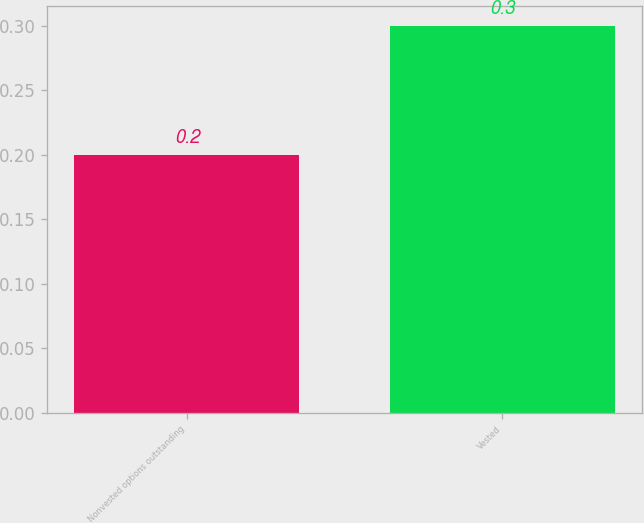<chart> <loc_0><loc_0><loc_500><loc_500><bar_chart><fcel>Nonvested options outstanding<fcel>Vested<nl><fcel>0.2<fcel>0.3<nl></chart> 